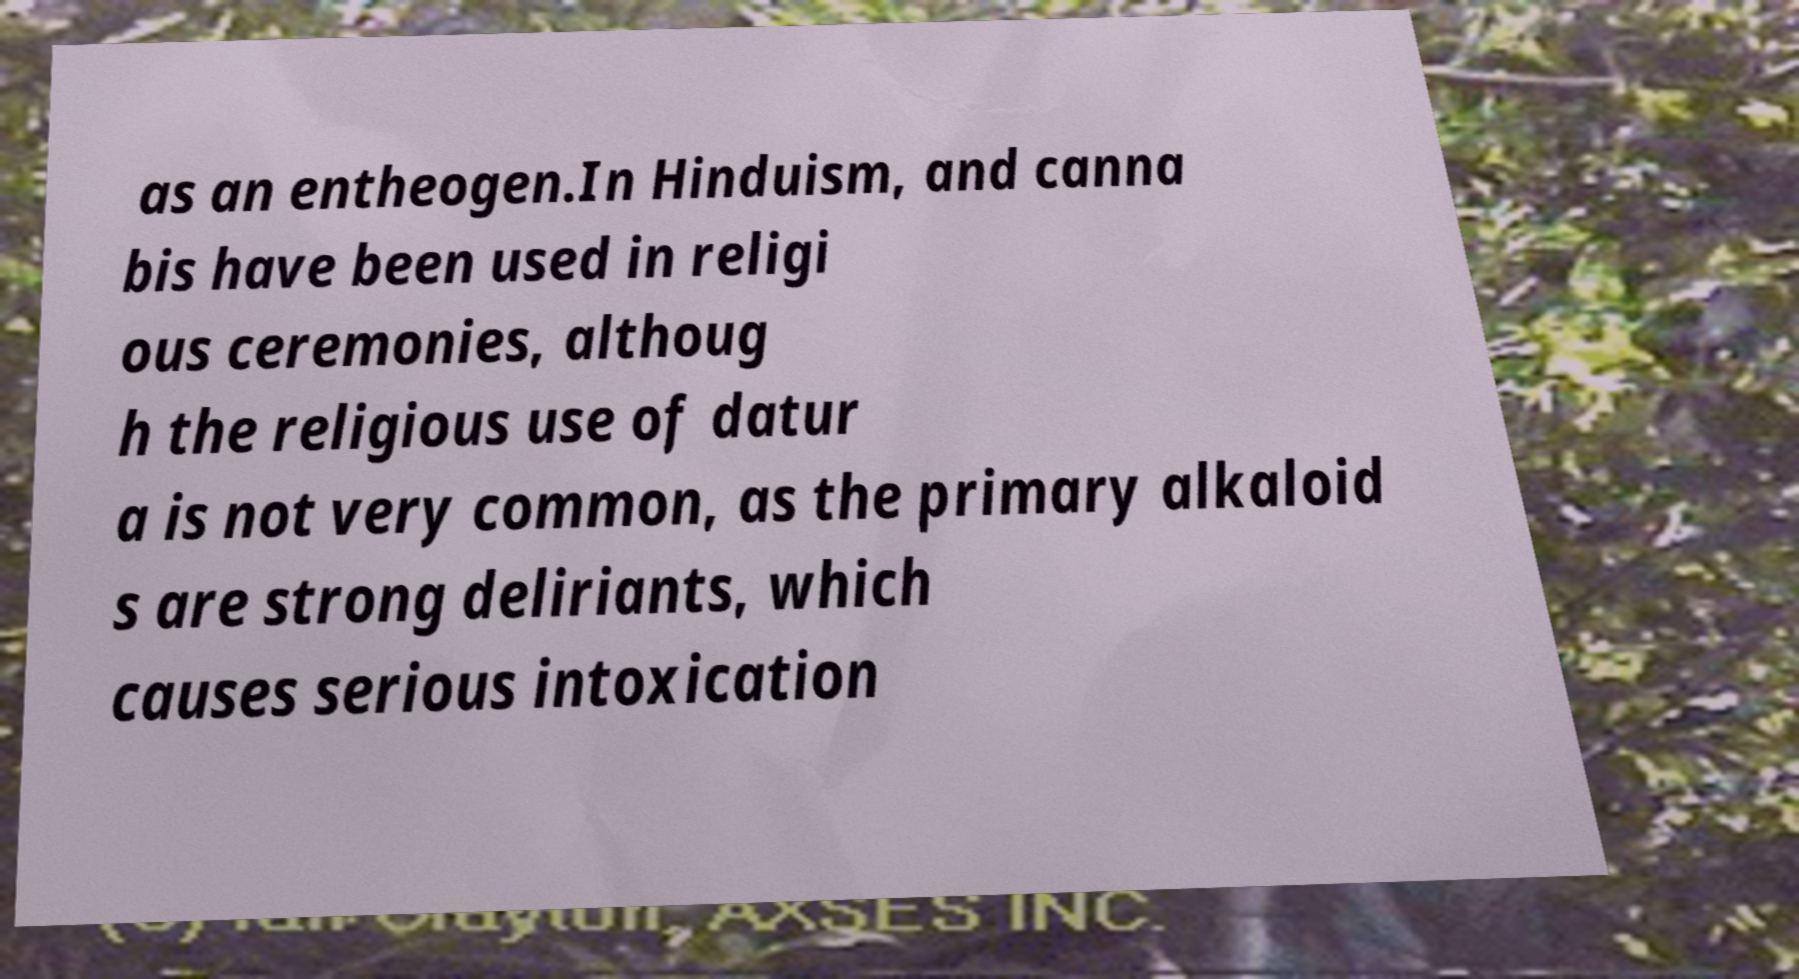For documentation purposes, I need the text within this image transcribed. Could you provide that? as an entheogen.In Hinduism, and canna bis have been used in religi ous ceremonies, althoug h the religious use of datur a is not very common, as the primary alkaloid s are strong deliriants, which causes serious intoxication 